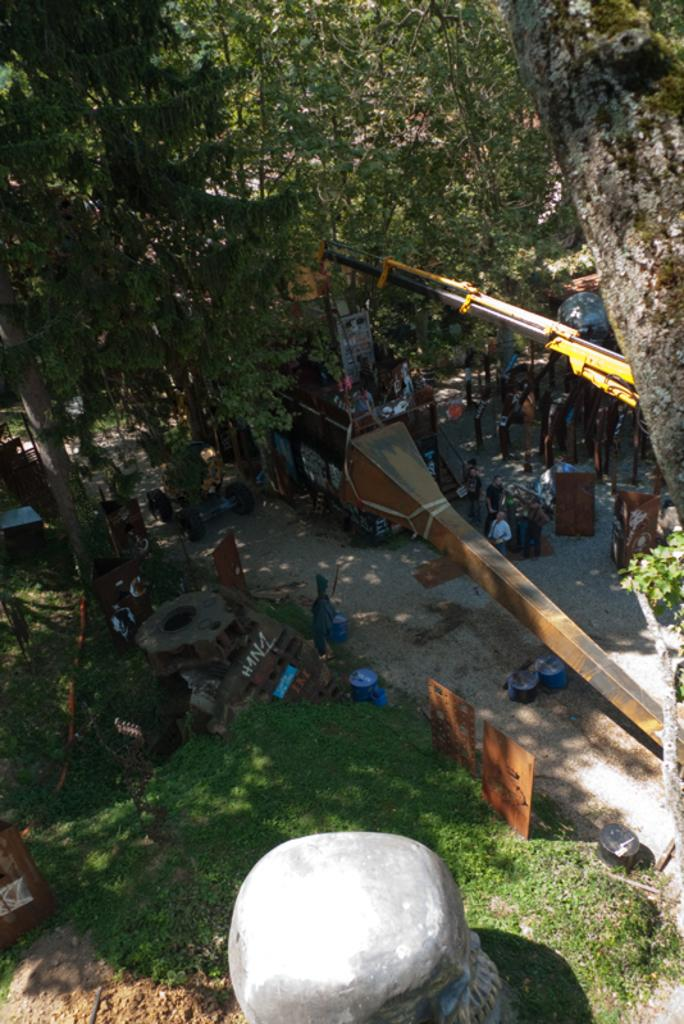What is the main subject of the image? The main subject of the image is a crane. What is the crane doing in the image? The crane is lifting a metal object in the image. What type of natural environment can be seen in the image? There is grass visible in the image, which suggests a natural environment. What other objects are present in the image? There is a rock, boards, and other objects in the image. Are there any people in the image? Yes, there are people in the image. What can be seen in the background of the image? There are trees in the background of the image. What type of machine is being used to play basketball in the image? There is no machine or basketball present in the image. 